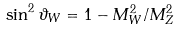Convert formula to latex. <formula><loc_0><loc_0><loc_500><loc_500>\sin ^ { 2 } \vartheta _ { W } = 1 - M _ { W } ^ { 2 } / M _ { Z } ^ { 2 }</formula> 